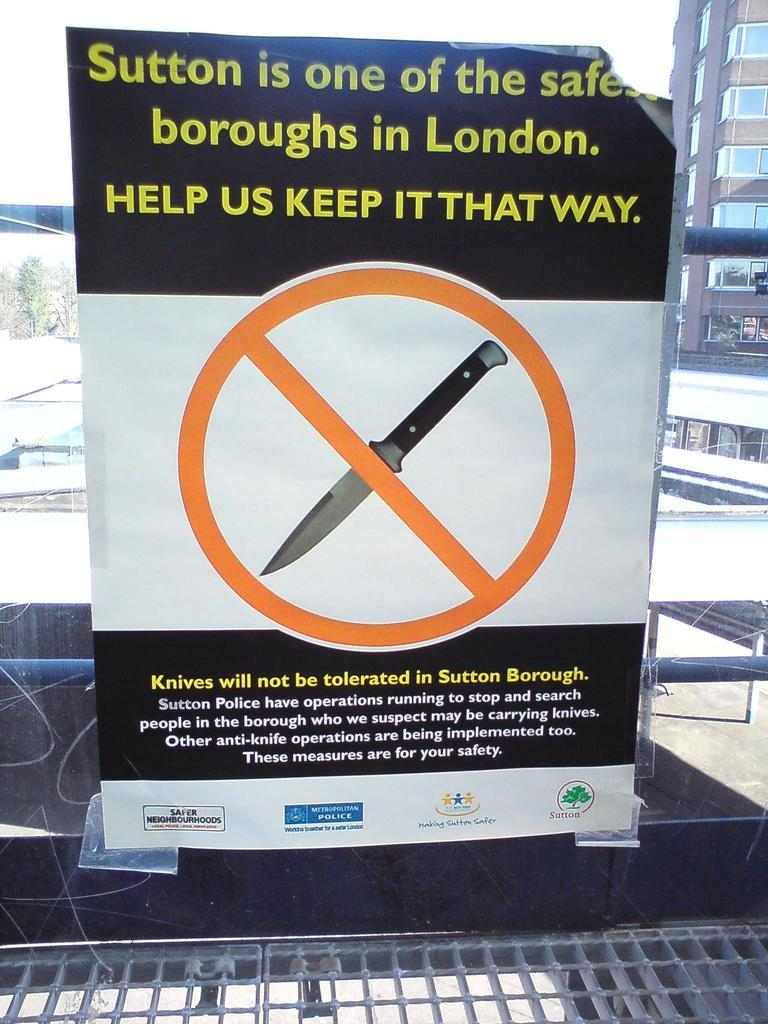<image>
Write a terse but informative summary of the picture. Sign hanging on a window showing a picture with a knife crossed out and says "Knives will not be tolerated in Sutton Borough". 